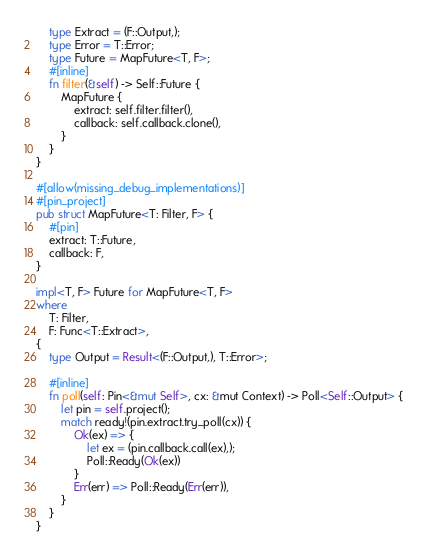Convert code to text. <code><loc_0><loc_0><loc_500><loc_500><_Rust_>    type Extract = (F::Output,);
    type Error = T::Error;
    type Future = MapFuture<T, F>;
    #[inline]
    fn filter(&self) -> Self::Future {
        MapFuture {
            extract: self.filter.filter(),
            callback: self.callback.clone(),
        }
    }
}

#[allow(missing_debug_implementations)]
#[pin_project]
pub struct MapFuture<T: Filter, F> {
    #[pin]
    extract: T::Future,
    callback: F,
}

impl<T, F> Future for MapFuture<T, F>
where
    T: Filter,
    F: Func<T::Extract>,
{
    type Output = Result<(F::Output,), T::Error>;

    #[inline]
    fn poll(self: Pin<&mut Self>, cx: &mut Context) -> Poll<Self::Output> {
        let pin = self.project();
        match ready!(pin.extract.try_poll(cx)) {
            Ok(ex) => {
                let ex = (pin.callback.call(ex),);
                Poll::Ready(Ok(ex))
            }
            Err(err) => Poll::Ready(Err(err)),
        }
    }
}
</code> 